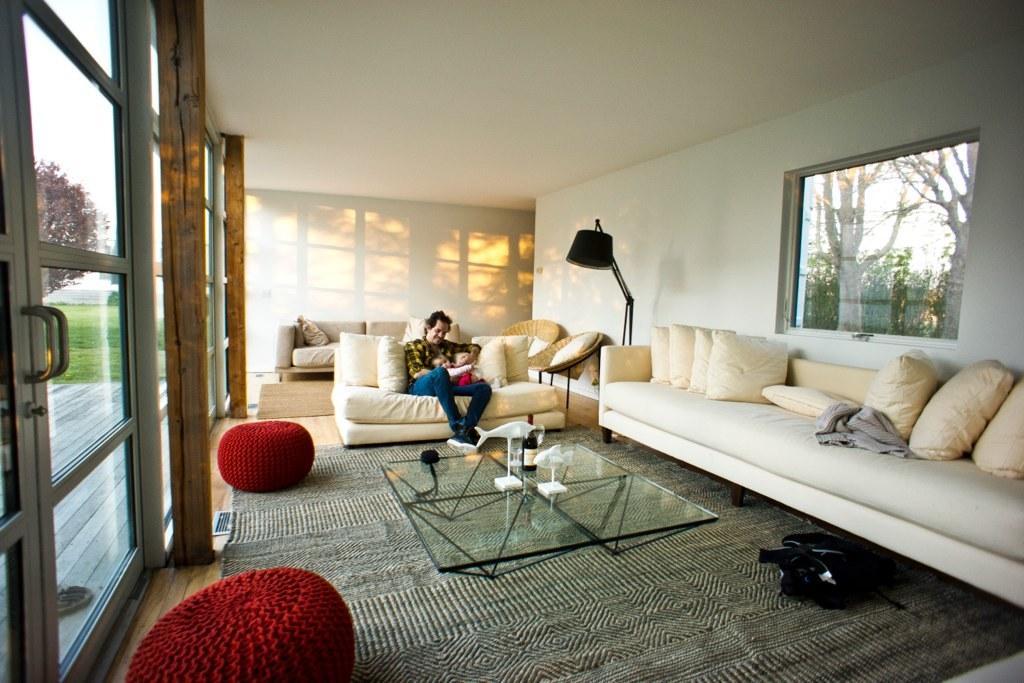Could you give a brief overview of what you see in this image? In this image, one person holding a baby sitting on the sofa. There is a sofa contains pillows. There is a table in front of the person. This person wearing colorful clothes and footwear. There is a window attached to the wall. There is a lamp in front of the wall. 